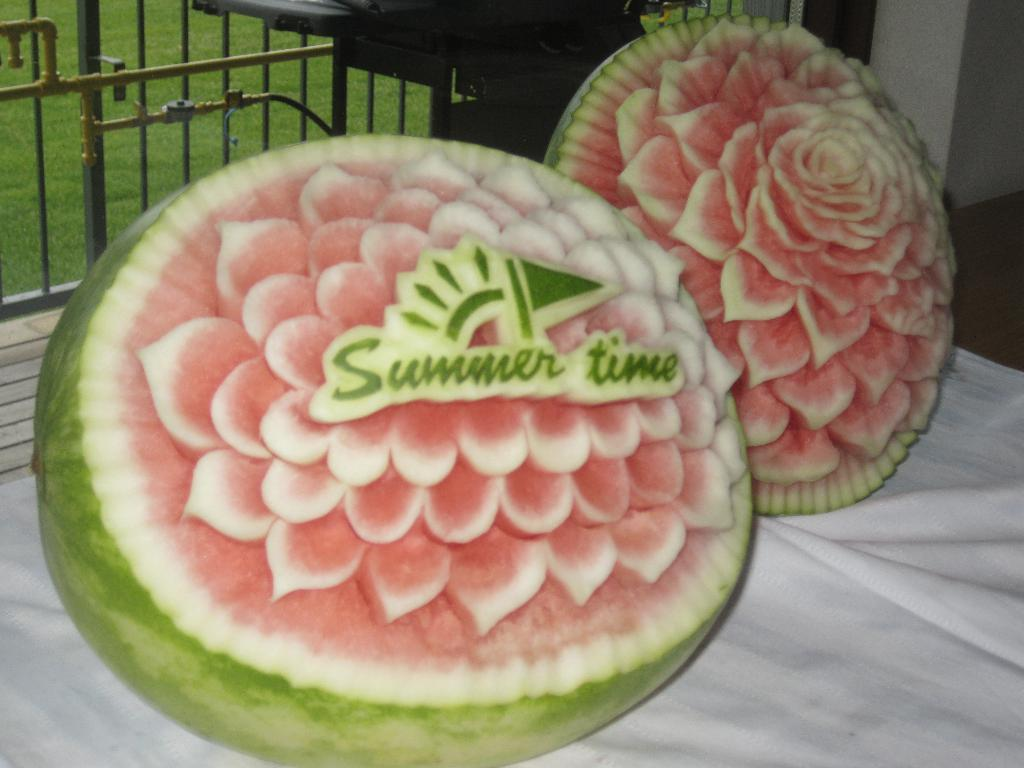What objects are featured in the image? There are two carved watermelons in the image. What are the watermelons placed on? The watermelons are on an object. What can be seen in the background of the image? In the background, there are items, pipes, iron grills, and grass visible. How do the sisters interact with the carved watermelons in the image? There are no sisters present in the image, so their interaction with the carved watermelons cannot be determined. 